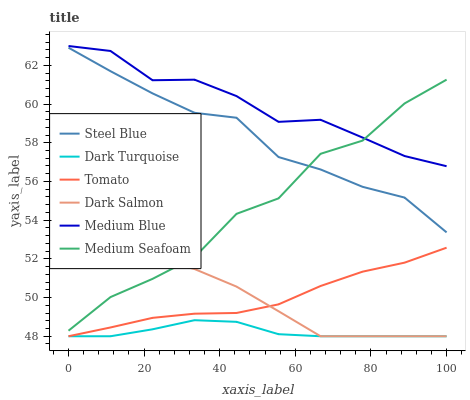Does Dark Turquoise have the minimum area under the curve?
Answer yes or no. Yes. Does Medium Blue have the maximum area under the curve?
Answer yes or no. Yes. Does Medium Blue have the minimum area under the curve?
Answer yes or no. No. Does Dark Turquoise have the maximum area under the curve?
Answer yes or no. No. Is Tomato the smoothest?
Answer yes or no. Yes. Is Medium Seafoam the roughest?
Answer yes or no. Yes. Is Dark Turquoise the smoothest?
Answer yes or no. No. Is Dark Turquoise the roughest?
Answer yes or no. No. Does Tomato have the lowest value?
Answer yes or no. Yes. Does Medium Blue have the lowest value?
Answer yes or no. No. Does Medium Blue have the highest value?
Answer yes or no. Yes. Does Dark Turquoise have the highest value?
Answer yes or no. No. Is Dark Salmon less than Medium Blue?
Answer yes or no. Yes. Is Medium Blue greater than Dark Turquoise?
Answer yes or no. Yes. Does Tomato intersect Dark Salmon?
Answer yes or no. Yes. Is Tomato less than Dark Salmon?
Answer yes or no. No. Is Tomato greater than Dark Salmon?
Answer yes or no. No. Does Dark Salmon intersect Medium Blue?
Answer yes or no. No. 